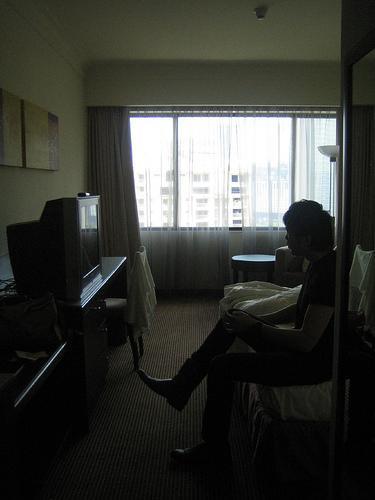How many people are there?
Give a very brief answer. 1. How many pieces of art on the wall?
Give a very brief answer. 2. 